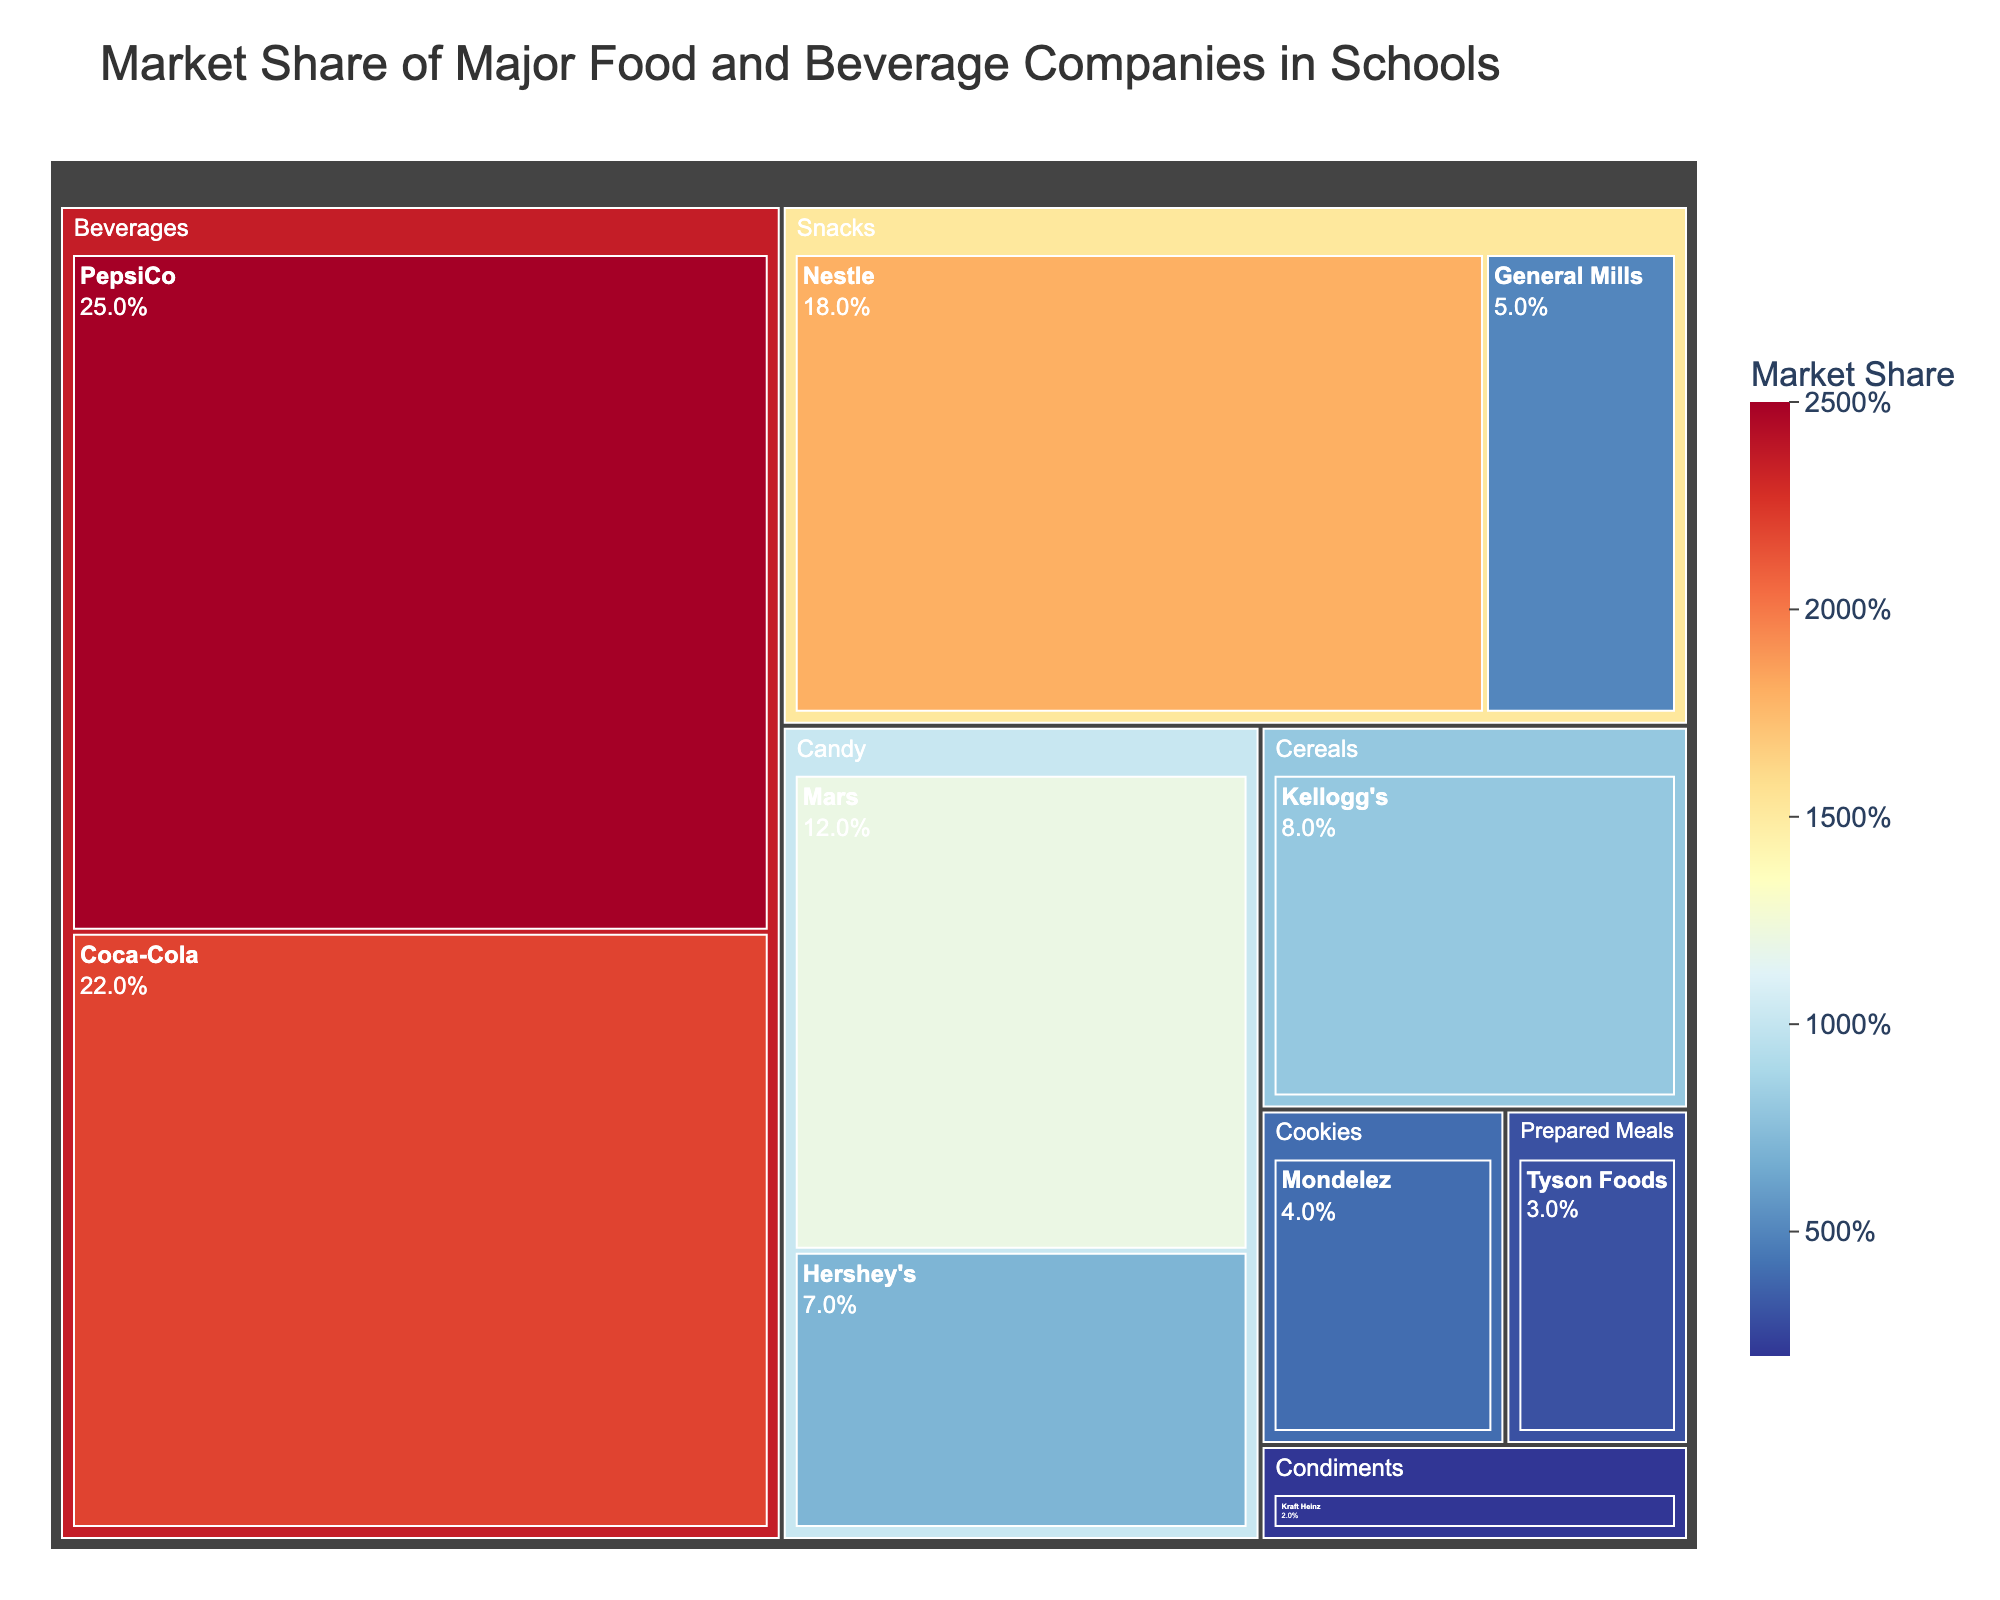How many companies are involved in the Beverages category? The Beverages category includes PepsiCo and Coca-Cola according to the figure. These are two companies.
Answer: 2 Which company has the highest market share in Snacks? In the Snacks category, the companies listed are Nestle and General Mills. Nestle has a market share of 18%, which is higher than General Mills' 5%.
Answer: Nestle What is the total market share for the Candy category? The Candy category includes Mars with 12% and Hershey's with 7%. Adding these gives 12% + 7%.
Answer: 19% Which category has the smallest market share? The figure shows that the Condiments category has the smallest market share, with Kraft Heinz at 2%.
Answer: Condiments What's the difference in market share between PepsiCo and Coca-Cola? PepsiCo has a market share of 25% and Coca-Cola has 22%. The difference is calculated as 25% - 22%.
Answer: 3% What is the combined market share of General Mills and Mondelez? General Mills has a market share of 5% and Mondelez has 4%. Adding these gives 5% + 4%.
Answer: 9% Which category has more market share, Prepared Meals or Cookies? The figure shows that Tyson Foods in the Prepared Meals category has a market share of 3%, and Mondelez in the Cookies category has a market share of 4%. Cookies have a higher market share than Prepared Meals.
Answer: Cookies What's the average market share of companies in the Beverages category? The Beverages category includes PepsiCo with 25% and Coca-Cola with 22%. The average is calculated as (25% + 22%) / 2.
Answer: 23.5% Which company has the smallest market share among all listed? The company with the smallest market share shown in the figure is Kraft Heinz with a 2% market share in the Condiments category.
Answer: Kraft Heinz How many companies are listed in the figure? The treemap lists the following companies: PepsiCo, Coca-Cola, Nestle, Mars, Kellogg's, Hershey's, General Mills, Mondelez, Tyson Foods, and Kraft Heinz. There are 10 companies in total.
Answer: 10 